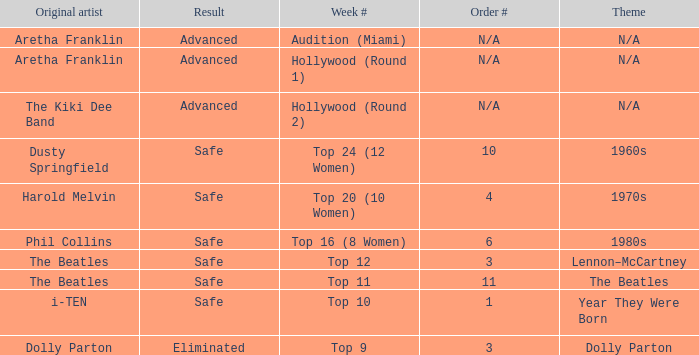What is the week number with Phil Collins as the original artist? Top 16 (8 Women). 